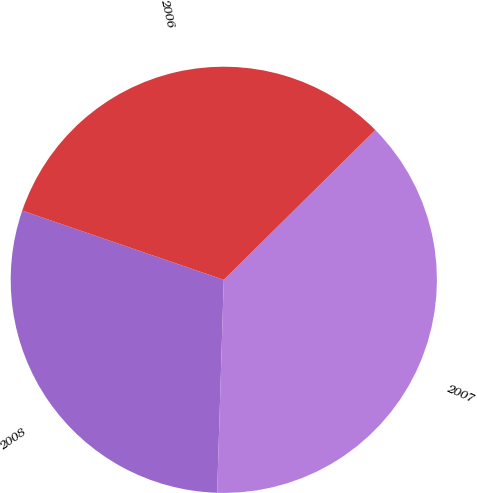Convert chart to OTSL. <chart><loc_0><loc_0><loc_500><loc_500><pie_chart><fcel>2008<fcel>2007<fcel>2006<nl><fcel>29.77%<fcel>37.91%<fcel>32.33%<nl></chart> 